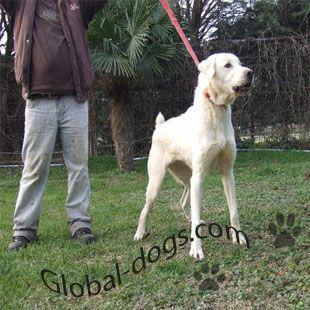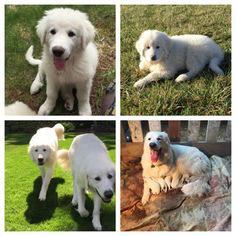The first image is the image on the left, the second image is the image on the right. For the images shown, is this caption "An image includes a large white dog on the grass next to a sitting puppy with its nose raised to the adult dog's face." true? Answer yes or no. No. The first image is the image on the left, the second image is the image on the right. Given the left and right images, does the statement "The right image contains exactly one white dog." hold true? Answer yes or no. No. 